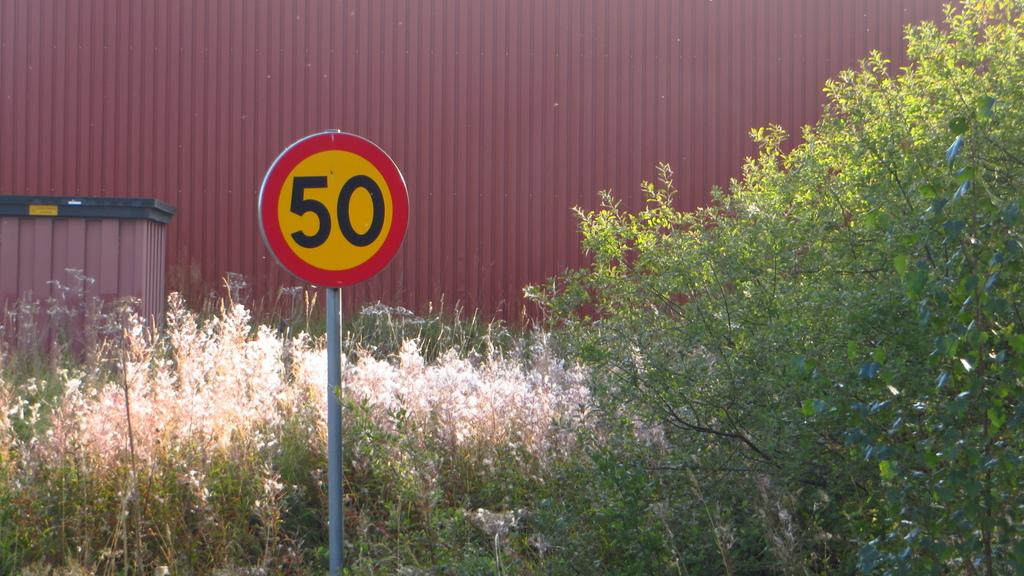<image>
Summarize the visual content of the image. A yellow sign with a red ring that says 50 is in front of bushes and a wall. 